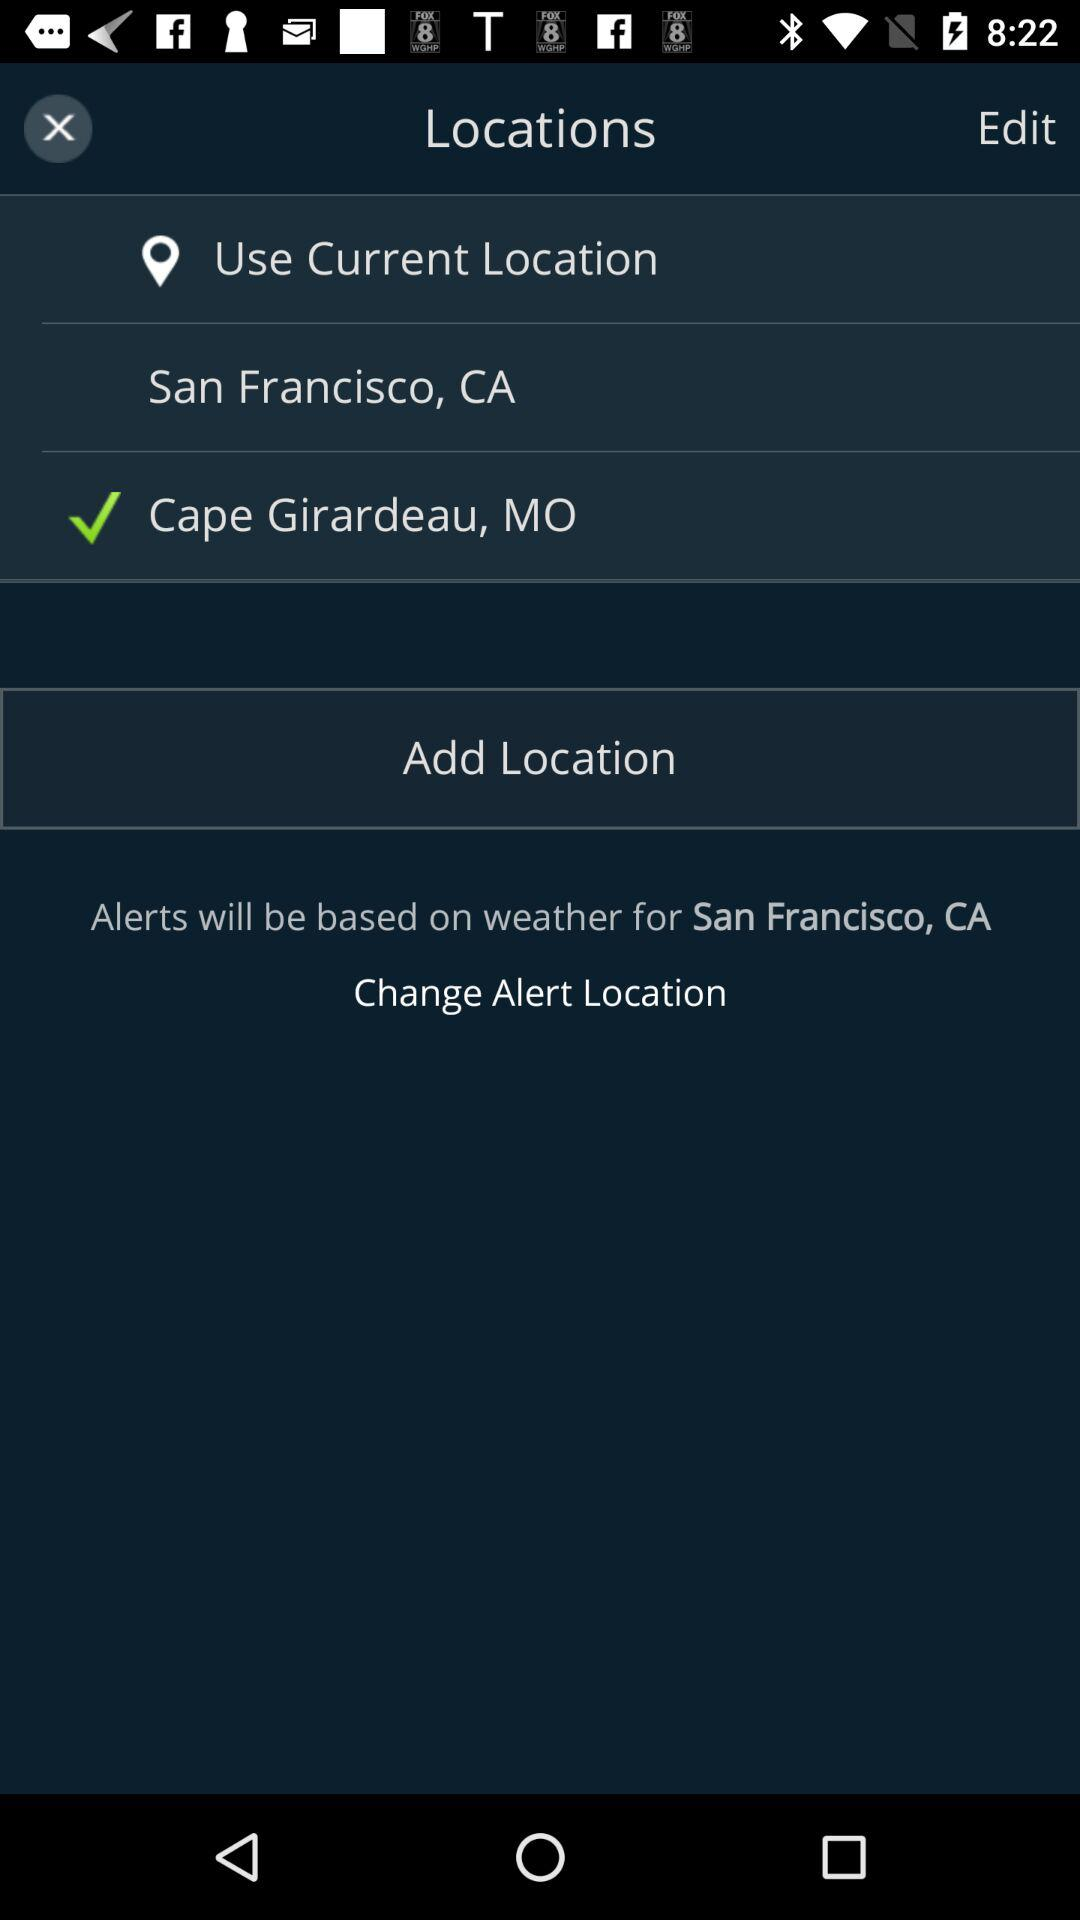What is the selected current location? The selected current location is Cape Girardeau, MO. 